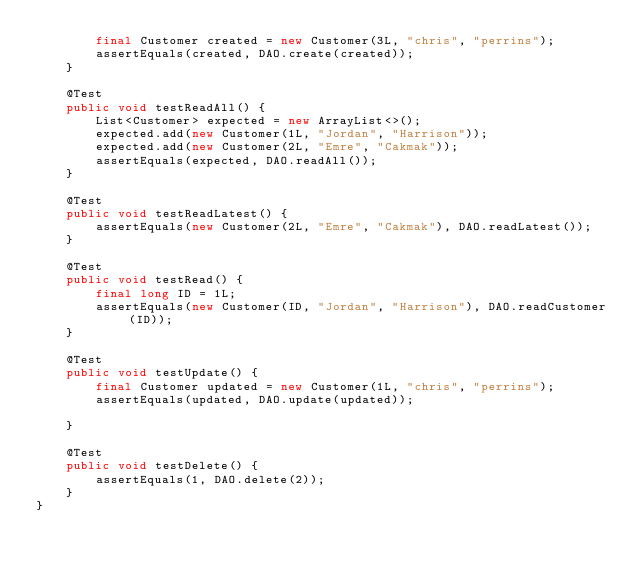Convert code to text. <code><loc_0><loc_0><loc_500><loc_500><_Java_>		final Customer created = new Customer(3L, "chris", "perrins");
		assertEquals(created, DAO.create(created));
	}

	@Test
	public void testReadAll() {
		List<Customer> expected = new ArrayList<>();
		expected.add(new Customer(1L, "Jordan", "Harrison"));
		expected.add(new Customer(2L, "Emre", "Cakmak"));
		assertEquals(expected, DAO.readAll());
	}

	@Test
	public void testReadLatest() {
		assertEquals(new Customer(2L, "Emre", "Cakmak"), DAO.readLatest());
	}

	@Test
	public void testRead() {
		final long ID = 1L;
		assertEquals(new Customer(ID, "Jordan", "Harrison"), DAO.readCustomer(ID));
	}

	@Test
	public void testUpdate() {
		final Customer updated = new Customer(1L, "chris", "perrins");
		assertEquals(updated, DAO.update(updated));

	}

	@Test
	public void testDelete() {
		assertEquals(1, DAO.delete(2));
	}
}</code> 